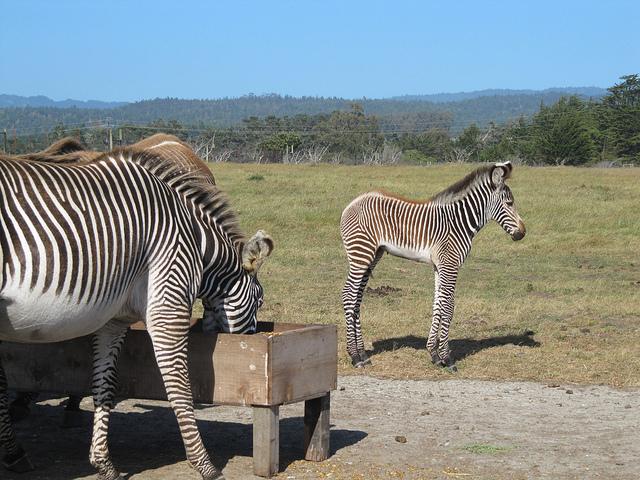What is the zebra eating?
Give a very brief answer. Hay. What number of zebra are feasting on green grass?
Be succinct. 0. Which zebra is older?
Give a very brief answer. One on left. Do you think that zebra in front is the baby zebra's mother?
Write a very short answer. Yes. Did people feed the zebra?
Answer briefly. Yes. 